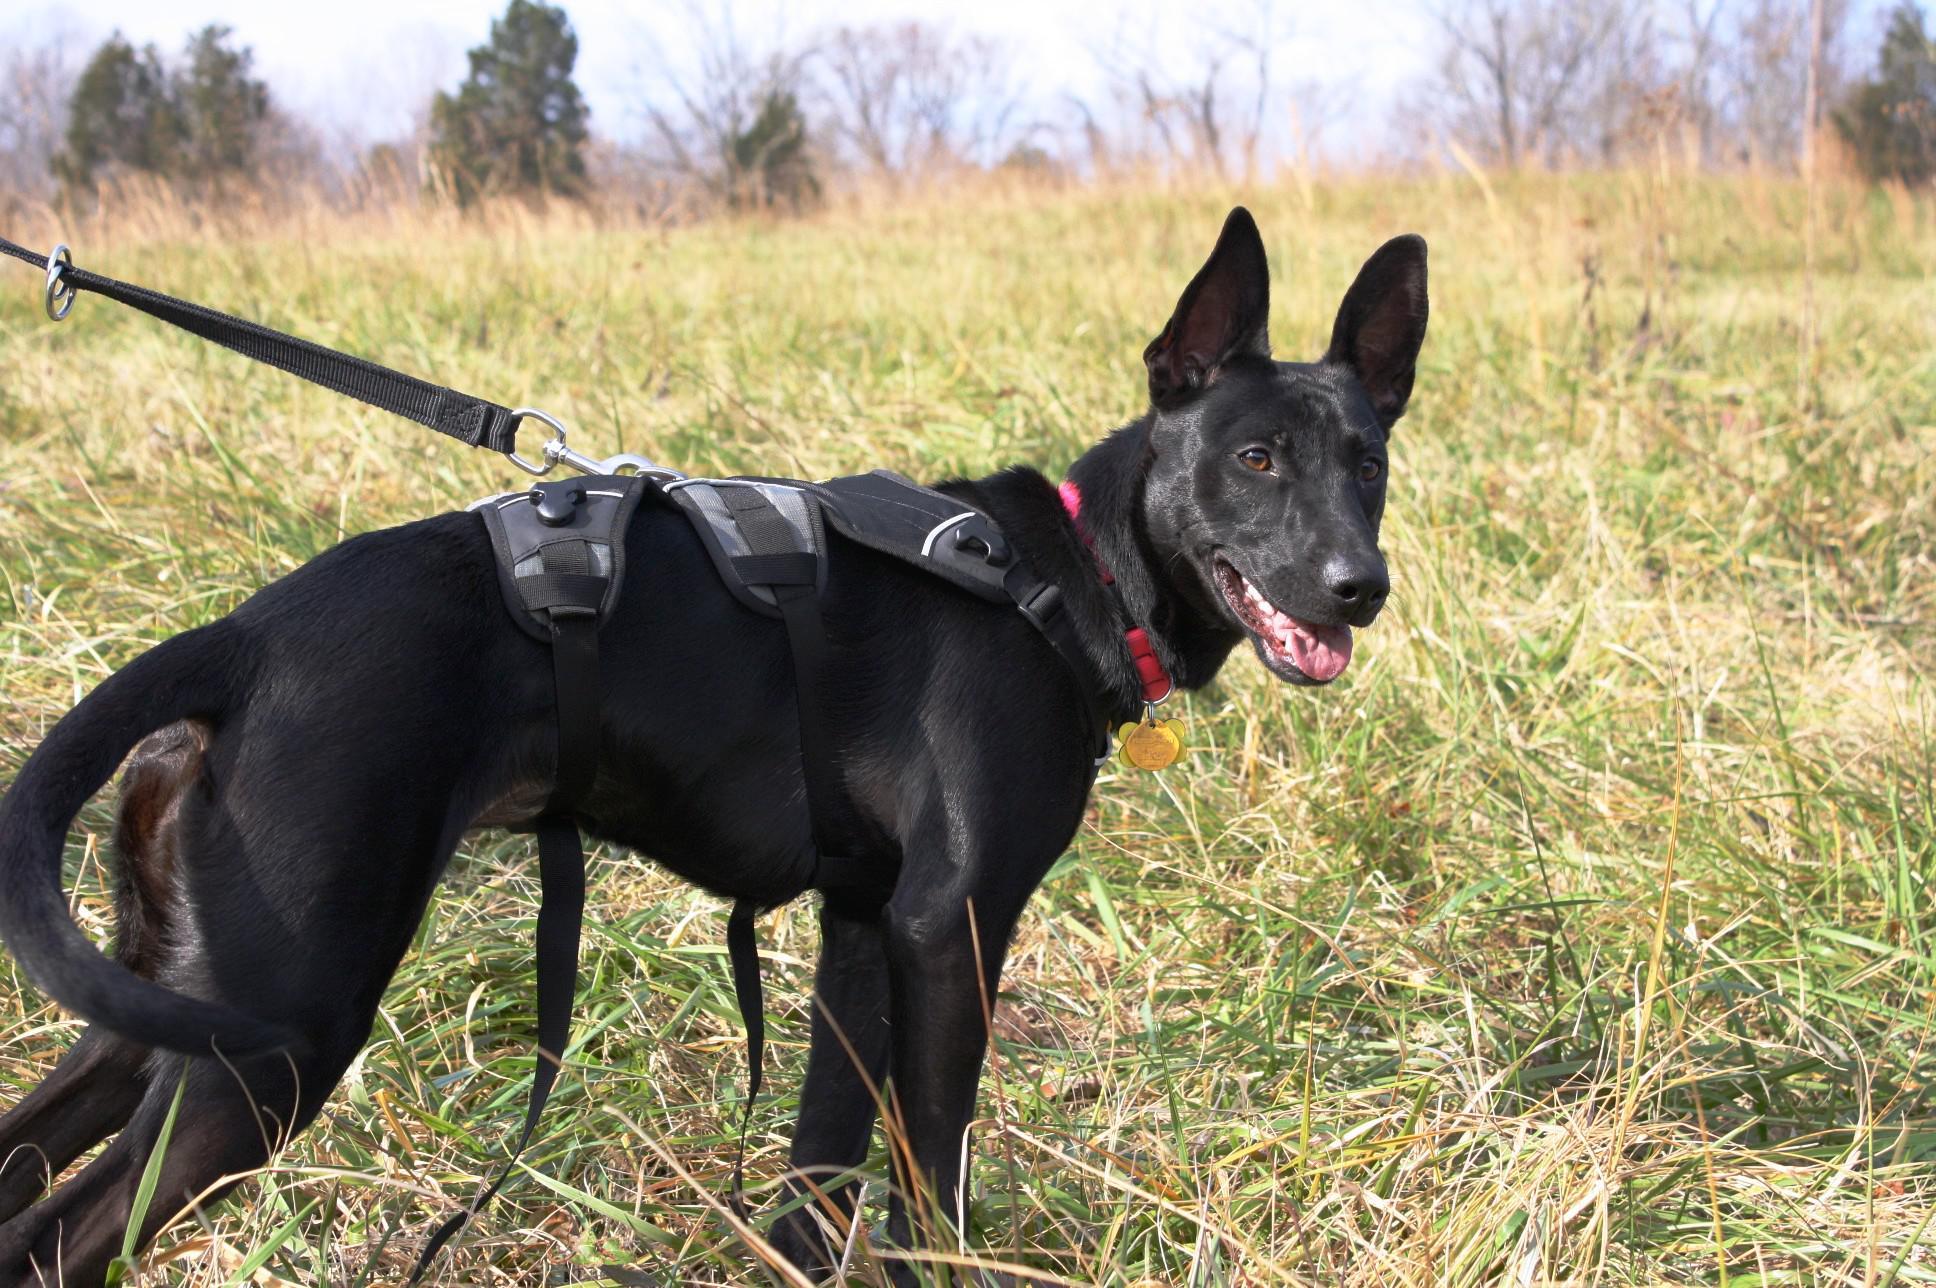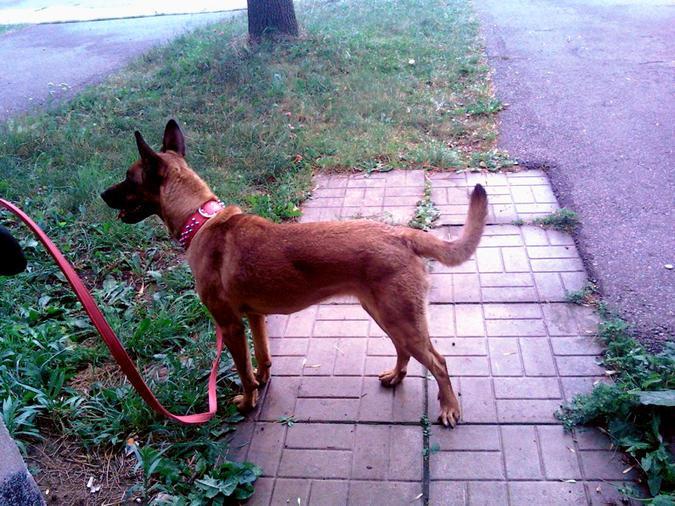The first image is the image on the left, the second image is the image on the right. Given the left and right images, does the statement "An image shows a black dog with erect, pointed ears." hold true? Answer yes or no. Yes. 